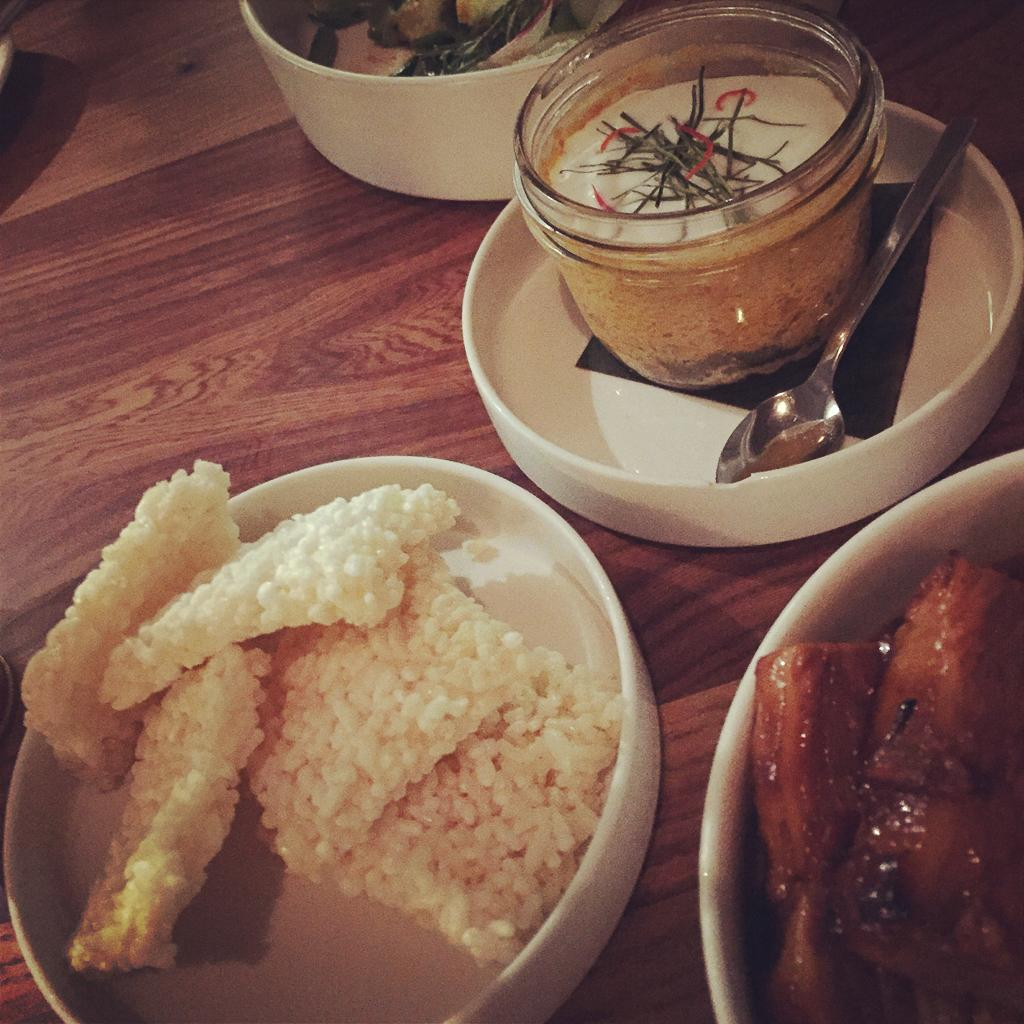What is present in the image that can be eaten? There is food in the image. What utensil is visible in the image? There is a spoon in the image. What color or type of surface is the spoon resting on? The spoon is on a brown-colored surface. What type of skin can be seen on the edge of the food in the image? There is no skin visible on the edge of the food in the image, as the facts provided do not mention any skin or flesh. 